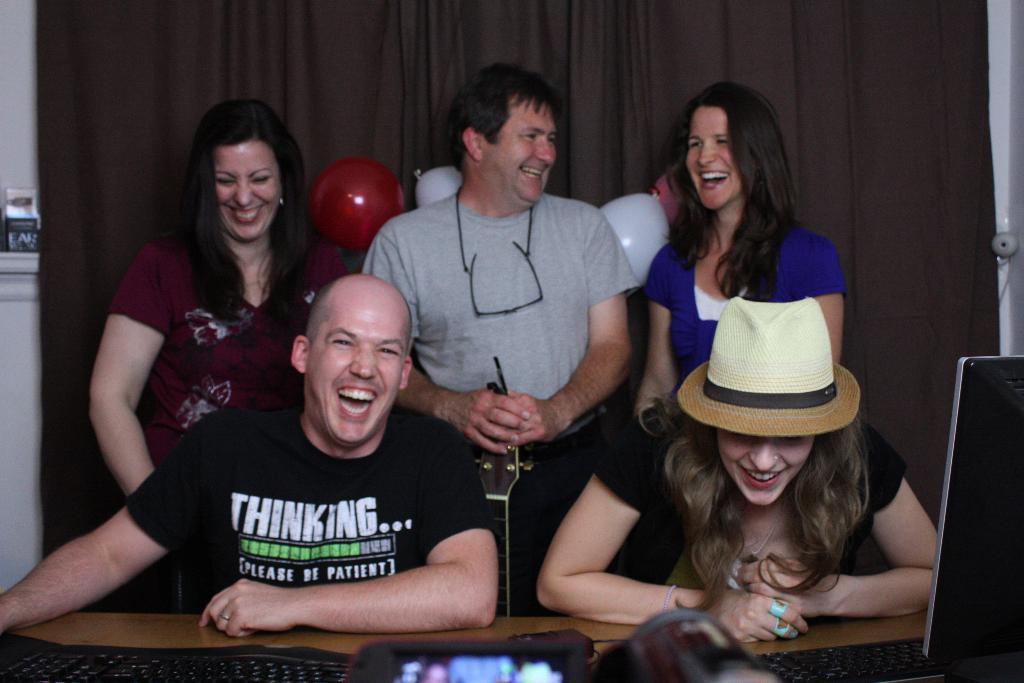Could you give a brief overview of what you see in this image? In this image we can see some people sitting and some are standing. There is a brown color curtain in the background. There are balloons. There is a monitor on the right side. There is a keyboard on the left bottom. 